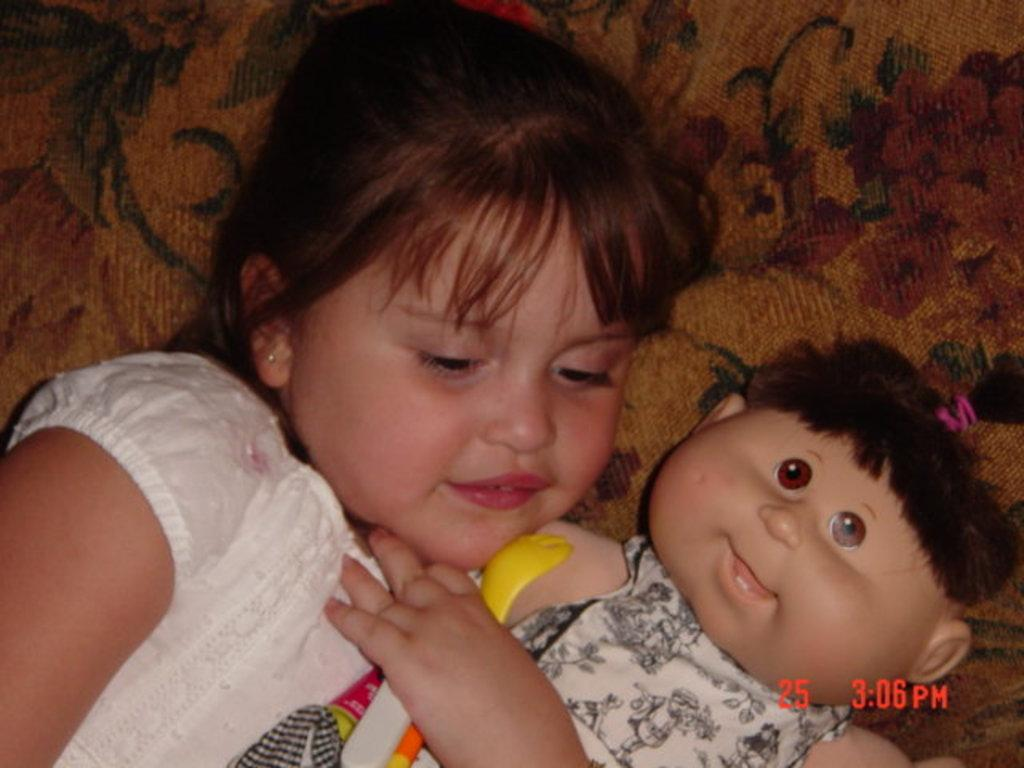What is the main subject of the image? The main subject of the image is a kid. What is the kid wearing in the image? The kid is wearing clothes in the image. What is the kid holding in the image? The kid is holding a doll with her hand in the image. What invention is the kid using to react to the situation in the image? There is no invention present in the image, and therefore no such reaction can be observed. What type of toothpaste is the kid using in the image? There is no toothpaste present in the image. 